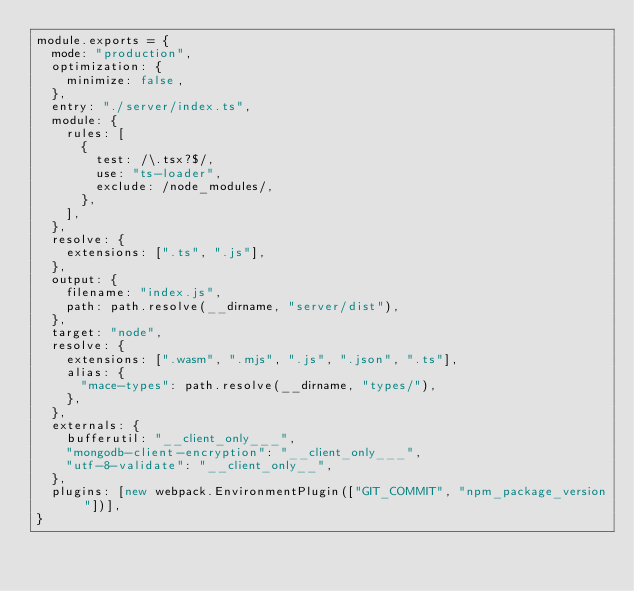Convert code to text. <code><loc_0><loc_0><loc_500><loc_500><_JavaScript_>module.exports = {
  mode: "production",
  optimization: {
    minimize: false,
  },
  entry: "./server/index.ts",
  module: {
    rules: [
      {
        test: /\.tsx?$/,
        use: "ts-loader",
        exclude: /node_modules/,
      },
    ],
  },
  resolve: {
    extensions: [".ts", ".js"],
  },
  output: {
    filename: "index.js",
    path: path.resolve(__dirname, "server/dist"),
  },
  target: "node",
  resolve: {
    extensions: [".wasm", ".mjs", ".js", ".json", ".ts"],
    alias: {
      "mace-types": path.resolve(__dirname, "types/"),
    },
  },
  externals: {
    bufferutil: "__client_only___",
    "mongodb-client-encryption": "__client_only___",
    "utf-8-validate": "__client_only__",
  },
  plugins: [new webpack.EnvironmentPlugin(["GIT_COMMIT", "npm_package_version"])],
}
</code> 